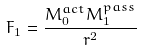Convert formula to latex. <formula><loc_0><loc_0><loc_500><loc_500>F _ { 1 } = { \frac { M _ { 0 } ^ { a c t } M _ { 1 } ^ { p a s s } } { r ^ { 2 } } }</formula> 